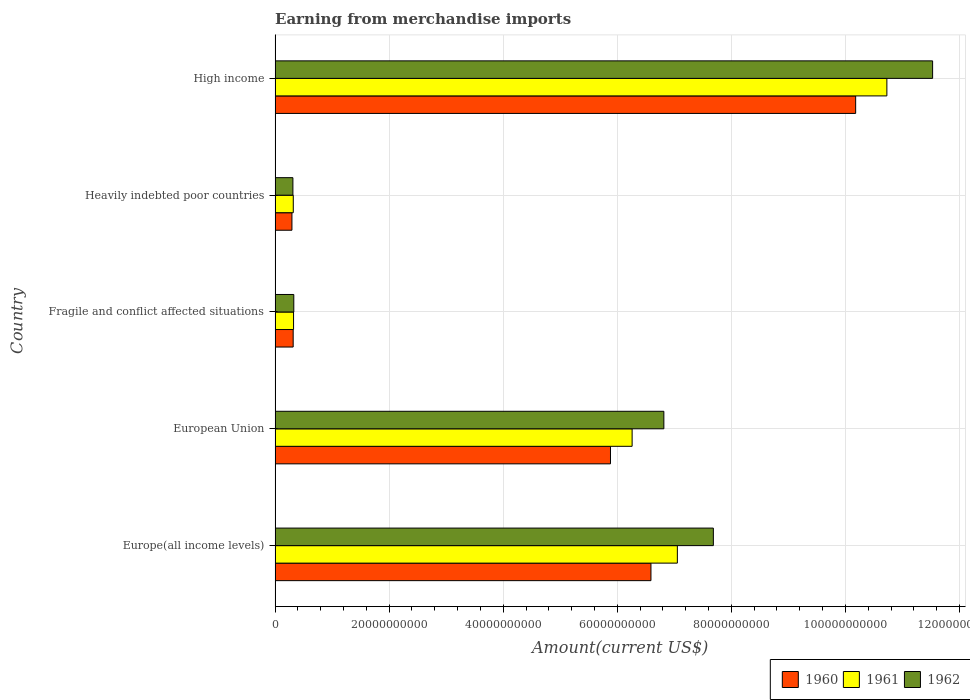How many different coloured bars are there?
Your answer should be compact. 3. Are the number of bars per tick equal to the number of legend labels?
Keep it short and to the point. Yes. Are the number of bars on each tick of the Y-axis equal?
Keep it short and to the point. Yes. How many bars are there on the 1st tick from the top?
Offer a very short reply. 3. What is the label of the 4th group of bars from the top?
Your response must be concise. European Union. What is the amount earned from merchandise imports in 1960 in High income?
Give a very brief answer. 1.02e+11. Across all countries, what is the maximum amount earned from merchandise imports in 1960?
Offer a very short reply. 1.02e+11. Across all countries, what is the minimum amount earned from merchandise imports in 1960?
Ensure brevity in your answer.  2.96e+09. In which country was the amount earned from merchandise imports in 1960 maximum?
Ensure brevity in your answer.  High income. In which country was the amount earned from merchandise imports in 1960 minimum?
Your response must be concise. Heavily indebted poor countries. What is the total amount earned from merchandise imports in 1960 in the graph?
Your response must be concise. 2.33e+11. What is the difference between the amount earned from merchandise imports in 1960 in Europe(all income levels) and that in Heavily indebted poor countries?
Keep it short and to the point. 6.30e+1. What is the difference between the amount earned from merchandise imports in 1962 in Europe(all income levels) and the amount earned from merchandise imports in 1961 in High income?
Ensure brevity in your answer.  -3.04e+1. What is the average amount earned from merchandise imports in 1960 per country?
Your answer should be very brief. 4.65e+1. What is the difference between the amount earned from merchandise imports in 1962 and amount earned from merchandise imports in 1960 in Europe(all income levels)?
Offer a terse response. 1.09e+1. In how many countries, is the amount earned from merchandise imports in 1962 greater than 96000000000 US$?
Your answer should be compact. 1. What is the ratio of the amount earned from merchandise imports in 1960 in European Union to that in Heavily indebted poor countries?
Keep it short and to the point. 19.9. Is the amount earned from merchandise imports in 1962 in European Union less than that in Heavily indebted poor countries?
Keep it short and to the point. No. What is the difference between the highest and the second highest amount earned from merchandise imports in 1960?
Your answer should be compact. 3.59e+1. What is the difference between the highest and the lowest amount earned from merchandise imports in 1961?
Offer a very short reply. 1.04e+11. In how many countries, is the amount earned from merchandise imports in 1961 greater than the average amount earned from merchandise imports in 1961 taken over all countries?
Provide a short and direct response. 3. Is the sum of the amount earned from merchandise imports in 1962 in Europe(all income levels) and European Union greater than the maximum amount earned from merchandise imports in 1960 across all countries?
Provide a succinct answer. Yes. What does the 2nd bar from the bottom in Fragile and conflict affected situations represents?
Keep it short and to the point. 1961. Is it the case that in every country, the sum of the amount earned from merchandise imports in 1961 and amount earned from merchandise imports in 1960 is greater than the amount earned from merchandise imports in 1962?
Make the answer very short. Yes. How many countries are there in the graph?
Your answer should be compact. 5. Are the values on the major ticks of X-axis written in scientific E-notation?
Your response must be concise. No. How many legend labels are there?
Offer a very short reply. 3. What is the title of the graph?
Provide a succinct answer. Earning from merchandise imports. What is the label or title of the X-axis?
Make the answer very short. Amount(current US$). What is the Amount(current US$) of 1960 in Europe(all income levels)?
Provide a succinct answer. 6.59e+1. What is the Amount(current US$) of 1961 in Europe(all income levels)?
Ensure brevity in your answer.  7.05e+1. What is the Amount(current US$) in 1962 in Europe(all income levels)?
Provide a short and direct response. 7.68e+1. What is the Amount(current US$) in 1960 in European Union?
Give a very brief answer. 5.88e+1. What is the Amount(current US$) of 1961 in European Union?
Give a very brief answer. 6.26e+1. What is the Amount(current US$) of 1962 in European Union?
Make the answer very short. 6.82e+1. What is the Amount(current US$) of 1960 in Fragile and conflict affected situations?
Make the answer very short. 3.17e+09. What is the Amount(current US$) of 1961 in Fragile and conflict affected situations?
Your answer should be very brief. 3.24e+09. What is the Amount(current US$) of 1962 in Fragile and conflict affected situations?
Offer a very short reply. 3.28e+09. What is the Amount(current US$) in 1960 in Heavily indebted poor countries?
Keep it short and to the point. 2.96e+09. What is the Amount(current US$) in 1961 in Heavily indebted poor countries?
Offer a terse response. 3.19e+09. What is the Amount(current US$) in 1962 in Heavily indebted poor countries?
Provide a succinct answer. 3.13e+09. What is the Amount(current US$) in 1960 in High income?
Your response must be concise. 1.02e+11. What is the Amount(current US$) in 1961 in High income?
Make the answer very short. 1.07e+11. What is the Amount(current US$) of 1962 in High income?
Offer a very short reply. 1.15e+11. Across all countries, what is the maximum Amount(current US$) in 1960?
Provide a short and direct response. 1.02e+11. Across all countries, what is the maximum Amount(current US$) of 1961?
Your answer should be compact. 1.07e+11. Across all countries, what is the maximum Amount(current US$) of 1962?
Your response must be concise. 1.15e+11. Across all countries, what is the minimum Amount(current US$) of 1960?
Keep it short and to the point. 2.96e+09. Across all countries, what is the minimum Amount(current US$) in 1961?
Your response must be concise. 3.19e+09. Across all countries, what is the minimum Amount(current US$) of 1962?
Keep it short and to the point. 3.13e+09. What is the total Amount(current US$) in 1960 in the graph?
Offer a terse response. 2.33e+11. What is the total Amount(current US$) of 1961 in the graph?
Provide a short and direct response. 2.47e+11. What is the total Amount(current US$) of 1962 in the graph?
Ensure brevity in your answer.  2.67e+11. What is the difference between the Amount(current US$) in 1960 in Europe(all income levels) and that in European Union?
Offer a terse response. 7.10e+09. What is the difference between the Amount(current US$) of 1961 in Europe(all income levels) and that in European Union?
Ensure brevity in your answer.  7.93e+09. What is the difference between the Amount(current US$) in 1962 in Europe(all income levels) and that in European Union?
Provide a short and direct response. 8.68e+09. What is the difference between the Amount(current US$) in 1960 in Europe(all income levels) and that in Fragile and conflict affected situations?
Provide a short and direct response. 6.27e+1. What is the difference between the Amount(current US$) in 1961 in Europe(all income levels) and that in Fragile and conflict affected situations?
Keep it short and to the point. 6.73e+1. What is the difference between the Amount(current US$) of 1962 in Europe(all income levels) and that in Fragile and conflict affected situations?
Ensure brevity in your answer.  7.36e+1. What is the difference between the Amount(current US$) in 1960 in Europe(all income levels) and that in Heavily indebted poor countries?
Provide a succinct answer. 6.30e+1. What is the difference between the Amount(current US$) in 1961 in Europe(all income levels) and that in Heavily indebted poor countries?
Your answer should be very brief. 6.73e+1. What is the difference between the Amount(current US$) of 1962 in Europe(all income levels) and that in Heavily indebted poor countries?
Make the answer very short. 7.37e+1. What is the difference between the Amount(current US$) of 1960 in Europe(all income levels) and that in High income?
Make the answer very short. -3.59e+1. What is the difference between the Amount(current US$) in 1961 in Europe(all income levels) and that in High income?
Provide a succinct answer. -3.67e+1. What is the difference between the Amount(current US$) in 1962 in Europe(all income levels) and that in High income?
Make the answer very short. -3.84e+1. What is the difference between the Amount(current US$) of 1960 in European Union and that in Fragile and conflict affected situations?
Offer a very short reply. 5.56e+1. What is the difference between the Amount(current US$) in 1961 in European Union and that in Fragile and conflict affected situations?
Provide a short and direct response. 5.94e+1. What is the difference between the Amount(current US$) in 1962 in European Union and that in Fragile and conflict affected situations?
Ensure brevity in your answer.  6.49e+1. What is the difference between the Amount(current US$) in 1960 in European Union and that in Heavily indebted poor countries?
Offer a terse response. 5.59e+1. What is the difference between the Amount(current US$) in 1961 in European Union and that in Heavily indebted poor countries?
Your response must be concise. 5.94e+1. What is the difference between the Amount(current US$) of 1962 in European Union and that in Heavily indebted poor countries?
Your answer should be very brief. 6.50e+1. What is the difference between the Amount(current US$) in 1960 in European Union and that in High income?
Ensure brevity in your answer.  -4.30e+1. What is the difference between the Amount(current US$) of 1961 in European Union and that in High income?
Offer a very short reply. -4.47e+1. What is the difference between the Amount(current US$) of 1962 in European Union and that in High income?
Your response must be concise. -4.71e+1. What is the difference between the Amount(current US$) in 1960 in Fragile and conflict affected situations and that in Heavily indebted poor countries?
Your response must be concise. 2.18e+08. What is the difference between the Amount(current US$) in 1961 in Fragile and conflict affected situations and that in Heavily indebted poor countries?
Ensure brevity in your answer.  4.90e+07. What is the difference between the Amount(current US$) of 1962 in Fragile and conflict affected situations and that in Heavily indebted poor countries?
Your response must be concise. 1.55e+08. What is the difference between the Amount(current US$) in 1960 in Fragile and conflict affected situations and that in High income?
Your response must be concise. -9.86e+1. What is the difference between the Amount(current US$) of 1961 in Fragile and conflict affected situations and that in High income?
Provide a short and direct response. -1.04e+11. What is the difference between the Amount(current US$) of 1962 in Fragile and conflict affected situations and that in High income?
Your answer should be very brief. -1.12e+11. What is the difference between the Amount(current US$) in 1960 in Heavily indebted poor countries and that in High income?
Make the answer very short. -9.88e+1. What is the difference between the Amount(current US$) in 1961 in Heavily indebted poor countries and that in High income?
Make the answer very short. -1.04e+11. What is the difference between the Amount(current US$) of 1962 in Heavily indebted poor countries and that in High income?
Your answer should be very brief. -1.12e+11. What is the difference between the Amount(current US$) in 1960 in Europe(all income levels) and the Amount(current US$) in 1961 in European Union?
Give a very brief answer. 3.30e+09. What is the difference between the Amount(current US$) of 1960 in Europe(all income levels) and the Amount(current US$) of 1962 in European Union?
Give a very brief answer. -2.26e+09. What is the difference between the Amount(current US$) in 1961 in Europe(all income levels) and the Amount(current US$) in 1962 in European Union?
Make the answer very short. 2.37e+09. What is the difference between the Amount(current US$) in 1960 in Europe(all income levels) and the Amount(current US$) in 1961 in Fragile and conflict affected situations?
Provide a succinct answer. 6.27e+1. What is the difference between the Amount(current US$) in 1960 in Europe(all income levels) and the Amount(current US$) in 1962 in Fragile and conflict affected situations?
Offer a very short reply. 6.26e+1. What is the difference between the Amount(current US$) in 1961 in Europe(all income levels) and the Amount(current US$) in 1962 in Fragile and conflict affected situations?
Your answer should be very brief. 6.73e+1. What is the difference between the Amount(current US$) in 1960 in Europe(all income levels) and the Amount(current US$) in 1961 in Heavily indebted poor countries?
Keep it short and to the point. 6.27e+1. What is the difference between the Amount(current US$) in 1960 in Europe(all income levels) and the Amount(current US$) in 1962 in Heavily indebted poor countries?
Give a very brief answer. 6.28e+1. What is the difference between the Amount(current US$) in 1961 in Europe(all income levels) and the Amount(current US$) in 1962 in Heavily indebted poor countries?
Offer a very short reply. 6.74e+1. What is the difference between the Amount(current US$) of 1960 in Europe(all income levels) and the Amount(current US$) of 1961 in High income?
Ensure brevity in your answer.  -4.14e+1. What is the difference between the Amount(current US$) in 1960 in Europe(all income levels) and the Amount(current US$) in 1962 in High income?
Your answer should be compact. -4.94e+1. What is the difference between the Amount(current US$) of 1961 in Europe(all income levels) and the Amount(current US$) of 1962 in High income?
Ensure brevity in your answer.  -4.48e+1. What is the difference between the Amount(current US$) of 1960 in European Union and the Amount(current US$) of 1961 in Fragile and conflict affected situations?
Provide a short and direct response. 5.56e+1. What is the difference between the Amount(current US$) in 1960 in European Union and the Amount(current US$) in 1962 in Fragile and conflict affected situations?
Make the answer very short. 5.55e+1. What is the difference between the Amount(current US$) in 1961 in European Union and the Amount(current US$) in 1962 in Fragile and conflict affected situations?
Give a very brief answer. 5.93e+1. What is the difference between the Amount(current US$) of 1960 in European Union and the Amount(current US$) of 1961 in Heavily indebted poor countries?
Keep it short and to the point. 5.56e+1. What is the difference between the Amount(current US$) of 1960 in European Union and the Amount(current US$) of 1962 in Heavily indebted poor countries?
Give a very brief answer. 5.57e+1. What is the difference between the Amount(current US$) in 1961 in European Union and the Amount(current US$) in 1962 in Heavily indebted poor countries?
Your response must be concise. 5.95e+1. What is the difference between the Amount(current US$) of 1960 in European Union and the Amount(current US$) of 1961 in High income?
Ensure brevity in your answer.  -4.85e+1. What is the difference between the Amount(current US$) of 1960 in European Union and the Amount(current US$) of 1962 in High income?
Your answer should be very brief. -5.65e+1. What is the difference between the Amount(current US$) in 1961 in European Union and the Amount(current US$) in 1962 in High income?
Provide a succinct answer. -5.27e+1. What is the difference between the Amount(current US$) of 1960 in Fragile and conflict affected situations and the Amount(current US$) of 1961 in Heavily indebted poor countries?
Your answer should be very brief. -1.74e+07. What is the difference between the Amount(current US$) of 1960 in Fragile and conflict affected situations and the Amount(current US$) of 1962 in Heavily indebted poor countries?
Ensure brevity in your answer.  4.64e+07. What is the difference between the Amount(current US$) of 1961 in Fragile and conflict affected situations and the Amount(current US$) of 1962 in Heavily indebted poor countries?
Your answer should be very brief. 1.13e+08. What is the difference between the Amount(current US$) of 1960 in Fragile and conflict affected situations and the Amount(current US$) of 1961 in High income?
Keep it short and to the point. -1.04e+11. What is the difference between the Amount(current US$) in 1960 in Fragile and conflict affected situations and the Amount(current US$) in 1962 in High income?
Provide a short and direct response. -1.12e+11. What is the difference between the Amount(current US$) of 1961 in Fragile and conflict affected situations and the Amount(current US$) of 1962 in High income?
Your response must be concise. -1.12e+11. What is the difference between the Amount(current US$) of 1960 in Heavily indebted poor countries and the Amount(current US$) of 1961 in High income?
Offer a very short reply. -1.04e+11. What is the difference between the Amount(current US$) in 1960 in Heavily indebted poor countries and the Amount(current US$) in 1962 in High income?
Provide a short and direct response. -1.12e+11. What is the difference between the Amount(current US$) in 1961 in Heavily indebted poor countries and the Amount(current US$) in 1962 in High income?
Provide a short and direct response. -1.12e+11. What is the average Amount(current US$) in 1960 per country?
Provide a succinct answer. 4.65e+1. What is the average Amount(current US$) of 1961 per country?
Make the answer very short. 4.94e+1. What is the average Amount(current US$) of 1962 per country?
Ensure brevity in your answer.  5.33e+1. What is the difference between the Amount(current US$) in 1960 and Amount(current US$) in 1961 in Europe(all income levels)?
Your answer should be very brief. -4.63e+09. What is the difference between the Amount(current US$) of 1960 and Amount(current US$) of 1962 in Europe(all income levels)?
Your response must be concise. -1.09e+1. What is the difference between the Amount(current US$) in 1961 and Amount(current US$) in 1962 in Europe(all income levels)?
Offer a terse response. -6.31e+09. What is the difference between the Amount(current US$) in 1960 and Amount(current US$) in 1961 in European Union?
Your answer should be very brief. -3.80e+09. What is the difference between the Amount(current US$) in 1960 and Amount(current US$) in 1962 in European Union?
Your response must be concise. -9.36e+09. What is the difference between the Amount(current US$) in 1961 and Amount(current US$) in 1962 in European Union?
Your answer should be compact. -5.56e+09. What is the difference between the Amount(current US$) of 1960 and Amount(current US$) of 1961 in Fragile and conflict affected situations?
Provide a short and direct response. -6.64e+07. What is the difference between the Amount(current US$) in 1960 and Amount(current US$) in 1962 in Fragile and conflict affected situations?
Your answer should be compact. -1.09e+08. What is the difference between the Amount(current US$) of 1961 and Amount(current US$) of 1962 in Fragile and conflict affected situations?
Provide a short and direct response. -4.24e+07. What is the difference between the Amount(current US$) in 1960 and Amount(current US$) in 1961 in Heavily indebted poor countries?
Provide a short and direct response. -2.35e+08. What is the difference between the Amount(current US$) in 1960 and Amount(current US$) in 1962 in Heavily indebted poor countries?
Offer a very short reply. -1.71e+08. What is the difference between the Amount(current US$) in 1961 and Amount(current US$) in 1962 in Heavily indebted poor countries?
Your answer should be compact. 6.38e+07. What is the difference between the Amount(current US$) of 1960 and Amount(current US$) of 1961 in High income?
Your answer should be very brief. -5.47e+09. What is the difference between the Amount(current US$) in 1960 and Amount(current US$) in 1962 in High income?
Make the answer very short. -1.35e+1. What is the difference between the Amount(current US$) of 1961 and Amount(current US$) of 1962 in High income?
Provide a succinct answer. -8.02e+09. What is the ratio of the Amount(current US$) in 1960 in Europe(all income levels) to that in European Union?
Your response must be concise. 1.12. What is the ratio of the Amount(current US$) in 1961 in Europe(all income levels) to that in European Union?
Make the answer very short. 1.13. What is the ratio of the Amount(current US$) in 1962 in Europe(all income levels) to that in European Union?
Your answer should be very brief. 1.13. What is the ratio of the Amount(current US$) in 1960 in Europe(all income levels) to that in Fragile and conflict affected situations?
Give a very brief answer. 20.77. What is the ratio of the Amount(current US$) in 1961 in Europe(all income levels) to that in Fragile and conflict affected situations?
Provide a succinct answer. 21.77. What is the ratio of the Amount(current US$) of 1962 in Europe(all income levels) to that in Fragile and conflict affected situations?
Your answer should be compact. 23.41. What is the ratio of the Amount(current US$) of 1960 in Europe(all income levels) to that in Heavily indebted poor countries?
Keep it short and to the point. 22.3. What is the ratio of the Amount(current US$) in 1961 in Europe(all income levels) to that in Heavily indebted poor countries?
Keep it short and to the point. 22.11. What is the ratio of the Amount(current US$) of 1962 in Europe(all income levels) to that in Heavily indebted poor countries?
Make the answer very short. 24.58. What is the ratio of the Amount(current US$) of 1960 in Europe(all income levels) to that in High income?
Your answer should be compact. 0.65. What is the ratio of the Amount(current US$) of 1961 in Europe(all income levels) to that in High income?
Offer a very short reply. 0.66. What is the ratio of the Amount(current US$) in 1962 in Europe(all income levels) to that in High income?
Make the answer very short. 0.67. What is the ratio of the Amount(current US$) of 1960 in European Union to that in Fragile and conflict affected situations?
Provide a succinct answer. 18.53. What is the ratio of the Amount(current US$) in 1961 in European Union to that in Fragile and conflict affected situations?
Provide a short and direct response. 19.32. What is the ratio of the Amount(current US$) of 1962 in European Union to that in Fragile and conflict affected situations?
Ensure brevity in your answer.  20.77. What is the ratio of the Amount(current US$) in 1960 in European Union to that in Heavily indebted poor countries?
Your answer should be very brief. 19.9. What is the ratio of the Amount(current US$) in 1961 in European Union to that in Heavily indebted poor countries?
Your response must be concise. 19.62. What is the ratio of the Amount(current US$) of 1962 in European Union to that in Heavily indebted poor countries?
Your response must be concise. 21.8. What is the ratio of the Amount(current US$) of 1960 in European Union to that in High income?
Your response must be concise. 0.58. What is the ratio of the Amount(current US$) in 1961 in European Union to that in High income?
Your answer should be compact. 0.58. What is the ratio of the Amount(current US$) of 1962 in European Union to that in High income?
Offer a very short reply. 0.59. What is the ratio of the Amount(current US$) of 1960 in Fragile and conflict affected situations to that in Heavily indebted poor countries?
Make the answer very short. 1.07. What is the ratio of the Amount(current US$) in 1961 in Fragile and conflict affected situations to that in Heavily indebted poor countries?
Offer a terse response. 1.02. What is the ratio of the Amount(current US$) in 1962 in Fragile and conflict affected situations to that in Heavily indebted poor countries?
Offer a terse response. 1.05. What is the ratio of the Amount(current US$) in 1960 in Fragile and conflict affected situations to that in High income?
Offer a terse response. 0.03. What is the ratio of the Amount(current US$) of 1961 in Fragile and conflict affected situations to that in High income?
Your answer should be very brief. 0.03. What is the ratio of the Amount(current US$) of 1962 in Fragile and conflict affected situations to that in High income?
Give a very brief answer. 0.03. What is the ratio of the Amount(current US$) of 1960 in Heavily indebted poor countries to that in High income?
Offer a very short reply. 0.03. What is the ratio of the Amount(current US$) of 1961 in Heavily indebted poor countries to that in High income?
Keep it short and to the point. 0.03. What is the ratio of the Amount(current US$) of 1962 in Heavily indebted poor countries to that in High income?
Keep it short and to the point. 0.03. What is the difference between the highest and the second highest Amount(current US$) of 1960?
Your response must be concise. 3.59e+1. What is the difference between the highest and the second highest Amount(current US$) of 1961?
Make the answer very short. 3.67e+1. What is the difference between the highest and the second highest Amount(current US$) in 1962?
Your answer should be compact. 3.84e+1. What is the difference between the highest and the lowest Amount(current US$) of 1960?
Keep it short and to the point. 9.88e+1. What is the difference between the highest and the lowest Amount(current US$) of 1961?
Your answer should be compact. 1.04e+11. What is the difference between the highest and the lowest Amount(current US$) in 1962?
Keep it short and to the point. 1.12e+11. 